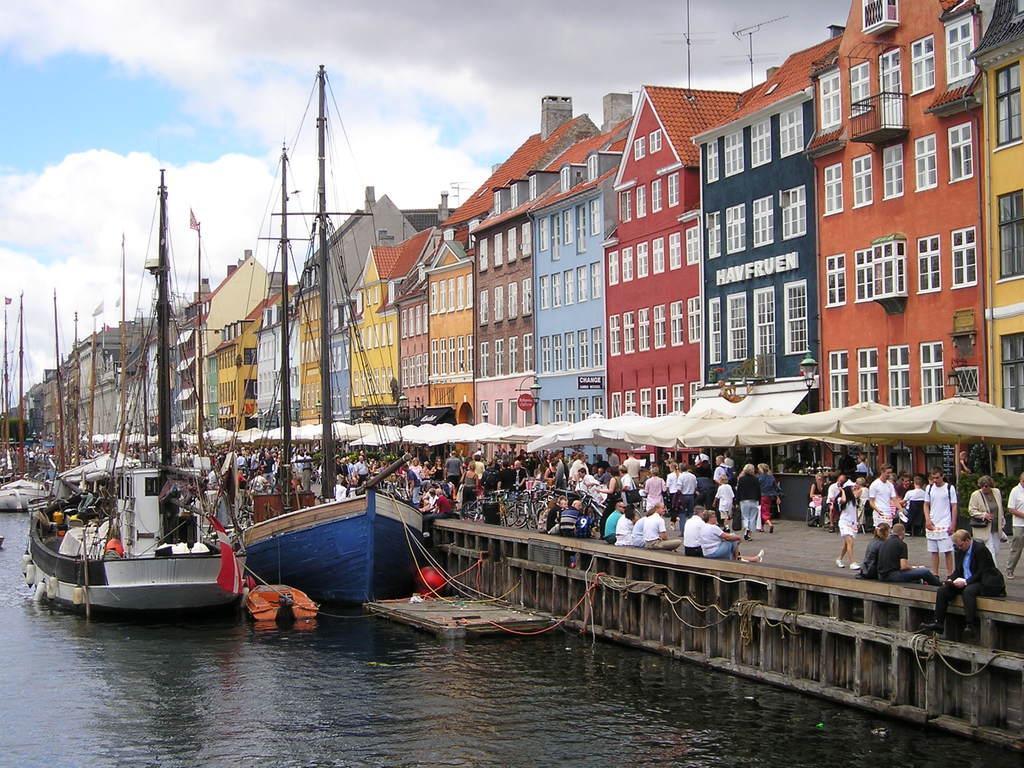How would you summarize this image in a sentence or two? This is the picture of inside of the city. At the back there are buildings. There are group of people on the road and there are tents on the road. At their left there is a water and boats on the water. At the top there is a sky. 